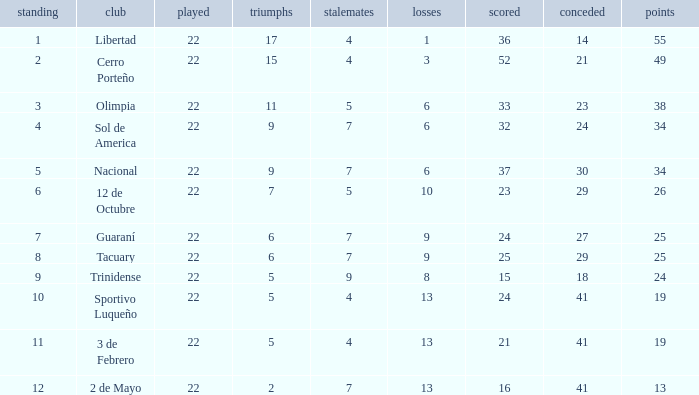What is the number of draws for the team with more than 8 losses and 13 points? 7.0. 